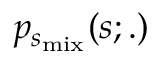<formula> <loc_0><loc_0><loc_500><loc_500>p _ { s _ { m i x } } ( s ; . )</formula> 